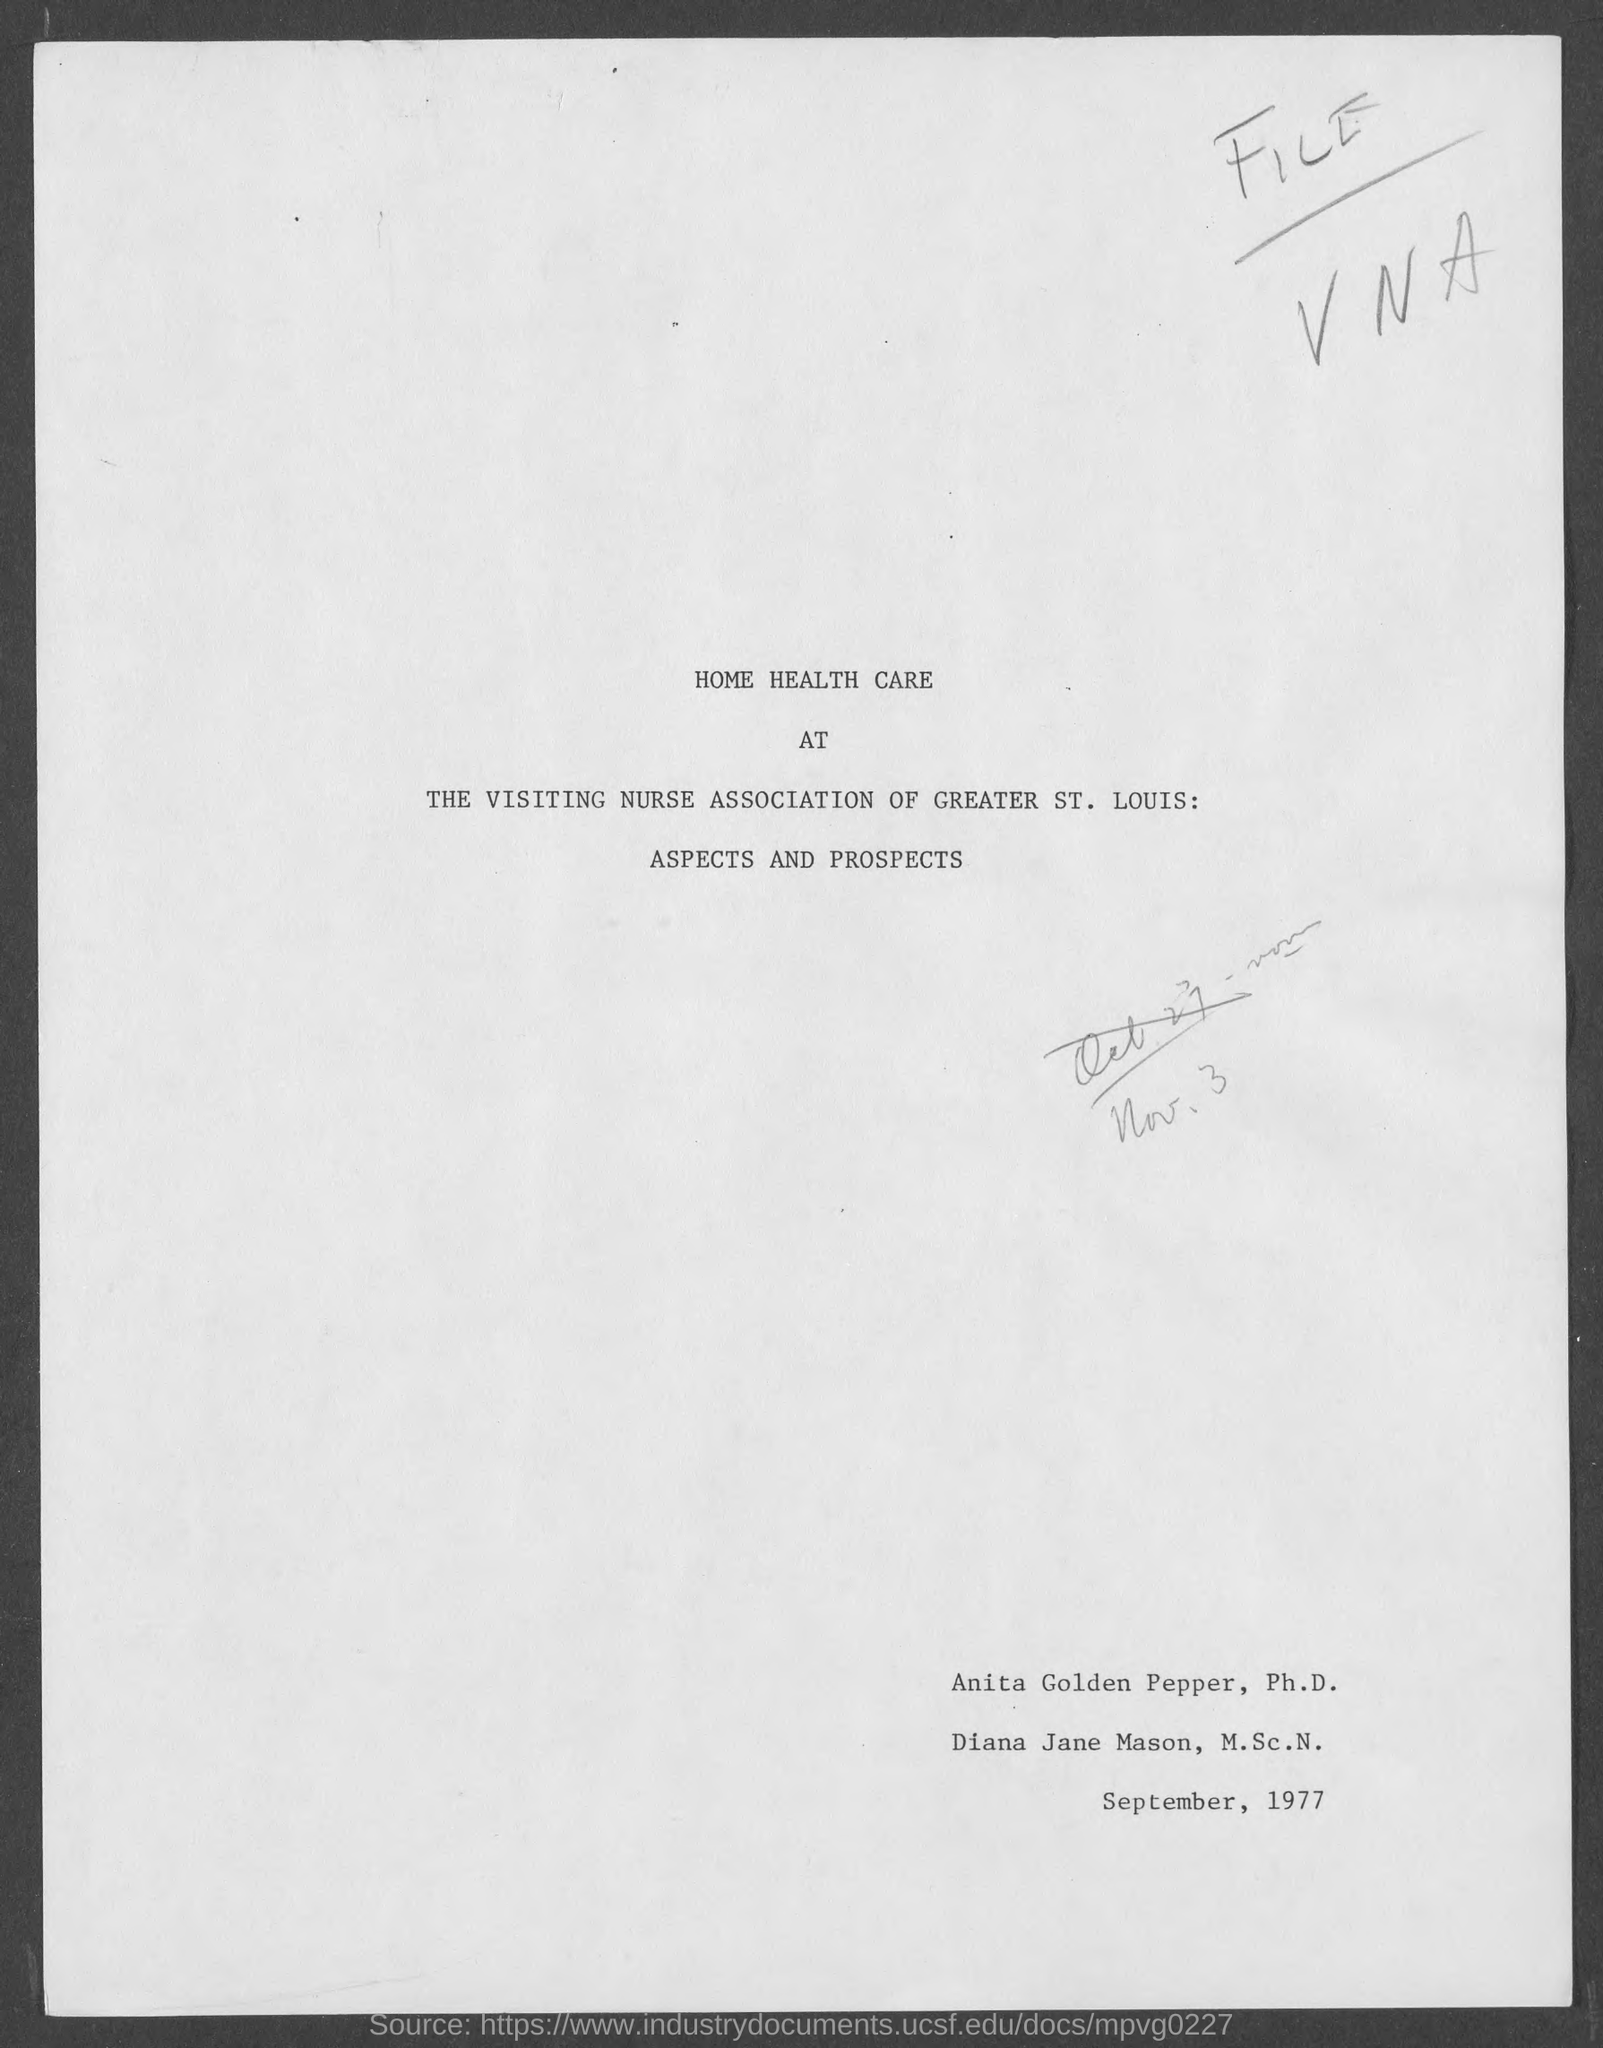Highlight a few significant elements in this photo. The second person in the document is named Diana Jane Mason. The first person in the document is named Anita Golden Pepper. 